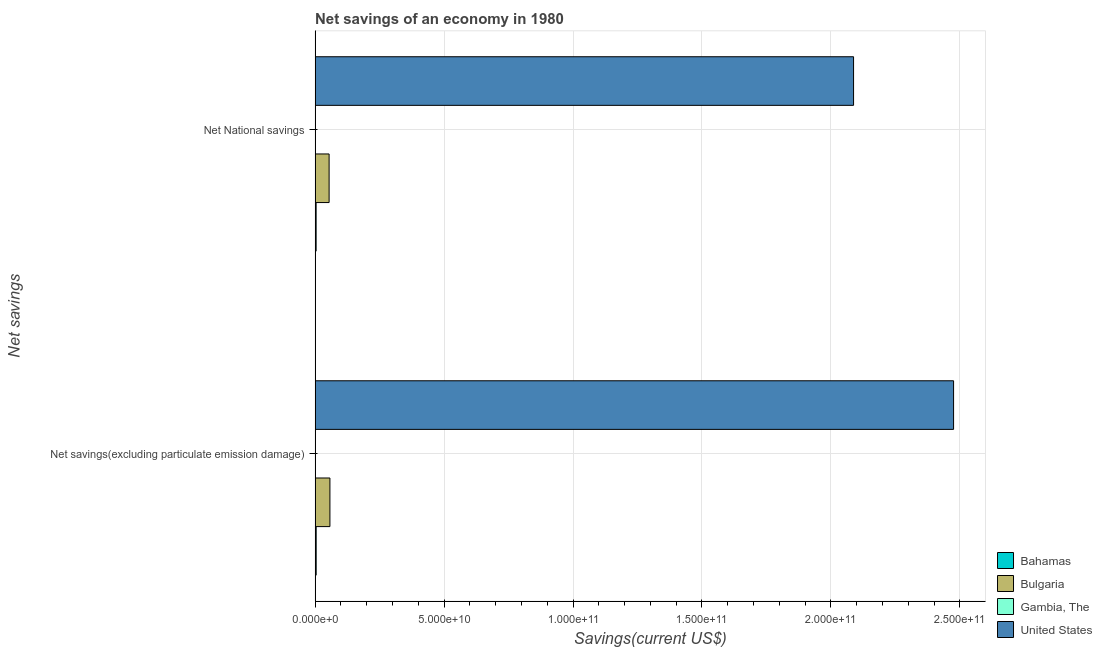How many different coloured bars are there?
Your answer should be very brief. 4. How many groups of bars are there?
Provide a succinct answer. 2. Are the number of bars per tick equal to the number of legend labels?
Make the answer very short. Yes. How many bars are there on the 2nd tick from the top?
Keep it short and to the point. 4. How many bars are there on the 2nd tick from the bottom?
Your answer should be compact. 4. What is the label of the 2nd group of bars from the top?
Offer a very short reply. Net savings(excluding particulate emission damage). What is the net savings(excluding particulate emission damage) in Bulgaria?
Offer a very short reply. 5.75e+09. Across all countries, what is the maximum net national savings?
Give a very brief answer. 2.09e+11. Across all countries, what is the minimum net savings(excluding particulate emission damage)?
Keep it short and to the point. 9.36e+06. In which country was the net savings(excluding particulate emission damage) minimum?
Ensure brevity in your answer.  Gambia, The. What is the total net savings(excluding particulate emission damage) in the graph?
Offer a very short reply. 2.54e+11. What is the difference between the net national savings in Bulgaria and that in Gambia, The?
Provide a short and direct response. 5.42e+09. What is the difference between the net savings(excluding particulate emission damage) in Bulgaria and the net national savings in Gambia, The?
Your answer should be very brief. 5.74e+09. What is the average net national savings per country?
Provide a succinct answer. 5.37e+1. What is the difference between the net savings(excluding particulate emission damage) and net national savings in United States?
Give a very brief answer. 3.88e+1. In how many countries, is the net savings(excluding particulate emission damage) greater than 40000000000 US$?
Ensure brevity in your answer.  1. What is the ratio of the net national savings in Bulgaria to that in United States?
Give a very brief answer. 0.03. In how many countries, is the net savings(excluding particulate emission damage) greater than the average net savings(excluding particulate emission damage) taken over all countries?
Your answer should be compact. 1. Are all the bars in the graph horizontal?
Make the answer very short. Yes. How many countries are there in the graph?
Your response must be concise. 4. What is the difference between two consecutive major ticks on the X-axis?
Your response must be concise. 5.00e+1. Where does the legend appear in the graph?
Provide a short and direct response. Bottom right. How are the legend labels stacked?
Provide a short and direct response. Vertical. What is the title of the graph?
Give a very brief answer. Net savings of an economy in 1980. What is the label or title of the X-axis?
Your answer should be compact. Savings(current US$). What is the label or title of the Y-axis?
Give a very brief answer. Net savings. What is the Savings(current US$) of Bahamas in Net savings(excluding particulate emission damage)?
Make the answer very short. 4.13e+08. What is the Savings(current US$) in Bulgaria in Net savings(excluding particulate emission damage)?
Your answer should be very brief. 5.75e+09. What is the Savings(current US$) of Gambia, The in Net savings(excluding particulate emission damage)?
Offer a terse response. 9.36e+06. What is the Savings(current US$) in United States in Net savings(excluding particulate emission damage)?
Provide a short and direct response. 2.48e+11. What is the Savings(current US$) of Bahamas in Net National savings?
Provide a succinct answer. 3.95e+08. What is the Savings(current US$) in Bulgaria in Net National savings?
Provide a short and direct response. 5.43e+09. What is the Savings(current US$) in Gambia, The in Net National savings?
Make the answer very short. 9.80e+06. What is the Savings(current US$) of United States in Net National savings?
Provide a short and direct response. 2.09e+11. Across all Net savings, what is the maximum Savings(current US$) of Bahamas?
Your answer should be very brief. 4.13e+08. Across all Net savings, what is the maximum Savings(current US$) of Bulgaria?
Your response must be concise. 5.75e+09. Across all Net savings, what is the maximum Savings(current US$) in Gambia, The?
Your answer should be compact. 9.80e+06. Across all Net savings, what is the maximum Savings(current US$) of United States?
Keep it short and to the point. 2.48e+11. Across all Net savings, what is the minimum Savings(current US$) in Bahamas?
Offer a terse response. 3.95e+08. Across all Net savings, what is the minimum Savings(current US$) in Bulgaria?
Offer a terse response. 5.43e+09. Across all Net savings, what is the minimum Savings(current US$) in Gambia, The?
Make the answer very short. 9.36e+06. Across all Net savings, what is the minimum Savings(current US$) of United States?
Give a very brief answer. 2.09e+11. What is the total Savings(current US$) in Bahamas in the graph?
Give a very brief answer. 8.09e+08. What is the total Savings(current US$) in Bulgaria in the graph?
Provide a succinct answer. 1.12e+1. What is the total Savings(current US$) of Gambia, The in the graph?
Provide a short and direct response. 1.92e+07. What is the total Savings(current US$) of United States in the graph?
Provide a succinct answer. 4.56e+11. What is the difference between the Savings(current US$) in Bahamas in Net savings(excluding particulate emission damage) and that in Net National savings?
Your answer should be compact. 1.84e+07. What is the difference between the Savings(current US$) of Bulgaria in Net savings(excluding particulate emission damage) and that in Net National savings?
Your answer should be very brief. 3.13e+08. What is the difference between the Savings(current US$) of Gambia, The in Net savings(excluding particulate emission damage) and that in Net National savings?
Provide a short and direct response. -4.42e+05. What is the difference between the Savings(current US$) in United States in Net savings(excluding particulate emission damage) and that in Net National savings?
Provide a succinct answer. 3.88e+1. What is the difference between the Savings(current US$) in Bahamas in Net savings(excluding particulate emission damage) and the Savings(current US$) in Bulgaria in Net National savings?
Ensure brevity in your answer.  -5.02e+09. What is the difference between the Savings(current US$) in Bahamas in Net savings(excluding particulate emission damage) and the Savings(current US$) in Gambia, The in Net National savings?
Your answer should be very brief. 4.04e+08. What is the difference between the Savings(current US$) in Bahamas in Net savings(excluding particulate emission damage) and the Savings(current US$) in United States in Net National savings?
Your answer should be compact. -2.08e+11. What is the difference between the Savings(current US$) of Bulgaria in Net savings(excluding particulate emission damage) and the Savings(current US$) of Gambia, The in Net National savings?
Ensure brevity in your answer.  5.74e+09. What is the difference between the Savings(current US$) of Bulgaria in Net savings(excluding particulate emission damage) and the Savings(current US$) of United States in Net National savings?
Offer a very short reply. -2.03e+11. What is the difference between the Savings(current US$) of Gambia, The in Net savings(excluding particulate emission damage) and the Savings(current US$) of United States in Net National savings?
Keep it short and to the point. -2.09e+11. What is the average Savings(current US$) of Bahamas per Net savings?
Your answer should be very brief. 4.04e+08. What is the average Savings(current US$) of Bulgaria per Net savings?
Provide a short and direct response. 5.59e+09. What is the average Savings(current US$) in Gambia, The per Net savings?
Your answer should be very brief. 9.58e+06. What is the average Savings(current US$) in United States per Net savings?
Give a very brief answer. 2.28e+11. What is the difference between the Savings(current US$) of Bahamas and Savings(current US$) of Bulgaria in Net savings(excluding particulate emission damage)?
Your answer should be compact. -5.33e+09. What is the difference between the Savings(current US$) in Bahamas and Savings(current US$) in Gambia, The in Net savings(excluding particulate emission damage)?
Keep it short and to the point. 4.04e+08. What is the difference between the Savings(current US$) in Bahamas and Savings(current US$) in United States in Net savings(excluding particulate emission damage)?
Provide a short and direct response. -2.47e+11. What is the difference between the Savings(current US$) in Bulgaria and Savings(current US$) in Gambia, The in Net savings(excluding particulate emission damage)?
Offer a very short reply. 5.74e+09. What is the difference between the Savings(current US$) of Bulgaria and Savings(current US$) of United States in Net savings(excluding particulate emission damage)?
Offer a very short reply. -2.42e+11. What is the difference between the Savings(current US$) in Gambia, The and Savings(current US$) in United States in Net savings(excluding particulate emission damage)?
Keep it short and to the point. -2.48e+11. What is the difference between the Savings(current US$) of Bahamas and Savings(current US$) of Bulgaria in Net National savings?
Provide a short and direct response. -5.04e+09. What is the difference between the Savings(current US$) of Bahamas and Savings(current US$) of Gambia, The in Net National savings?
Provide a succinct answer. 3.85e+08. What is the difference between the Savings(current US$) of Bahamas and Savings(current US$) of United States in Net National savings?
Ensure brevity in your answer.  -2.08e+11. What is the difference between the Savings(current US$) in Bulgaria and Savings(current US$) in Gambia, The in Net National savings?
Offer a terse response. 5.42e+09. What is the difference between the Savings(current US$) of Bulgaria and Savings(current US$) of United States in Net National savings?
Offer a terse response. -2.03e+11. What is the difference between the Savings(current US$) of Gambia, The and Savings(current US$) of United States in Net National savings?
Offer a very short reply. -2.09e+11. What is the ratio of the Savings(current US$) in Bahamas in Net savings(excluding particulate emission damage) to that in Net National savings?
Your response must be concise. 1.05. What is the ratio of the Savings(current US$) of Bulgaria in Net savings(excluding particulate emission damage) to that in Net National savings?
Your answer should be very brief. 1.06. What is the ratio of the Savings(current US$) of Gambia, The in Net savings(excluding particulate emission damage) to that in Net National savings?
Your answer should be compact. 0.95. What is the ratio of the Savings(current US$) of United States in Net savings(excluding particulate emission damage) to that in Net National savings?
Your answer should be compact. 1.19. What is the difference between the highest and the second highest Savings(current US$) in Bahamas?
Make the answer very short. 1.84e+07. What is the difference between the highest and the second highest Savings(current US$) in Bulgaria?
Provide a succinct answer. 3.13e+08. What is the difference between the highest and the second highest Savings(current US$) of Gambia, The?
Give a very brief answer. 4.42e+05. What is the difference between the highest and the second highest Savings(current US$) in United States?
Keep it short and to the point. 3.88e+1. What is the difference between the highest and the lowest Savings(current US$) in Bahamas?
Provide a succinct answer. 1.84e+07. What is the difference between the highest and the lowest Savings(current US$) of Bulgaria?
Your response must be concise. 3.13e+08. What is the difference between the highest and the lowest Savings(current US$) in Gambia, The?
Ensure brevity in your answer.  4.42e+05. What is the difference between the highest and the lowest Savings(current US$) of United States?
Provide a short and direct response. 3.88e+1. 